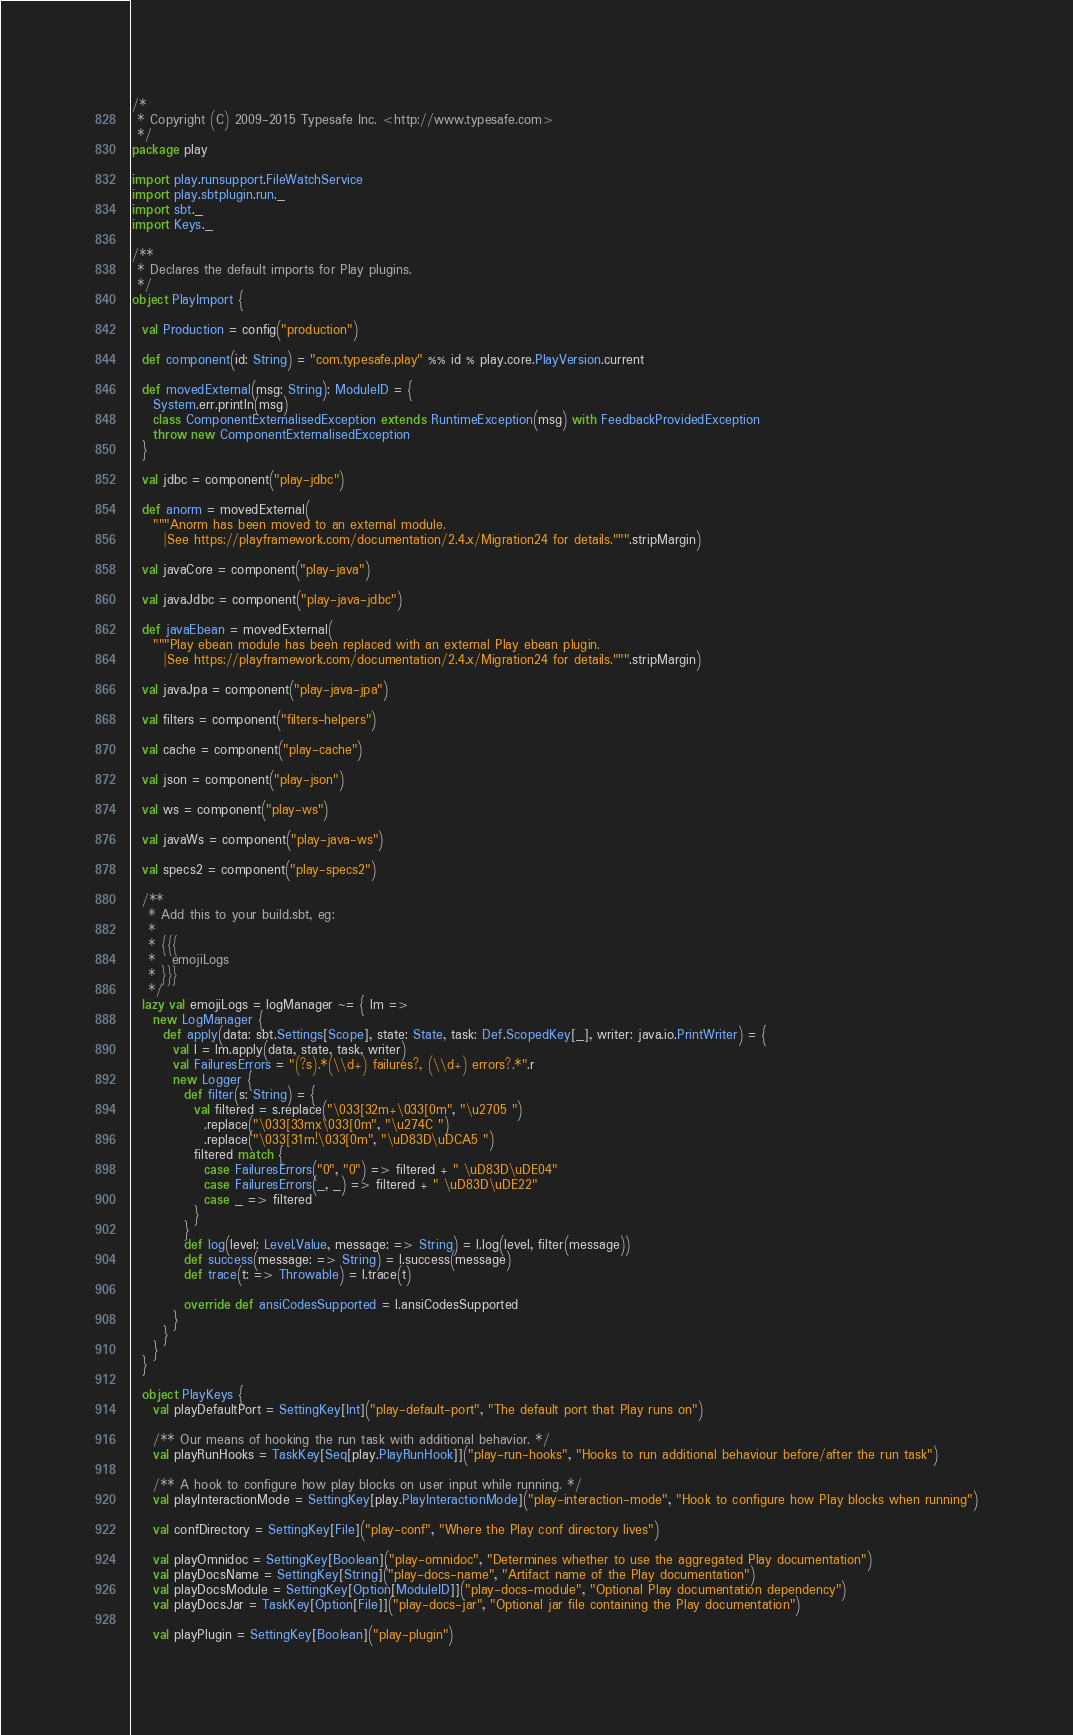<code> <loc_0><loc_0><loc_500><loc_500><_Scala_>/*
 * Copyright (C) 2009-2015 Typesafe Inc. <http://www.typesafe.com>
 */
package play

import play.runsupport.FileWatchService
import play.sbtplugin.run._
import sbt._
import Keys._

/**
 * Declares the default imports for Play plugins.
 */
object PlayImport {

  val Production = config("production")

  def component(id: String) = "com.typesafe.play" %% id % play.core.PlayVersion.current

  def movedExternal(msg: String): ModuleID = {
    System.err.println(msg)
    class ComponentExternalisedException extends RuntimeException(msg) with FeedbackProvidedException
    throw new ComponentExternalisedException
  }

  val jdbc = component("play-jdbc")

  def anorm = movedExternal(
    """Anorm has been moved to an external module.
      |See https://playframework.com/documentation/2.4.x/Migration24 for details.""".stripMargin)

  val javaCore = component("play-java")

  val javaJdbc = component("play-java-jdbc")

  def javaEbean = movedExternal(
    """Play ebean module has been replaced with an external Play ebean plugin.
      |See https://playframework.com/documentation/2.4.x/Migration24 for details.""".stripMargin)

  val javaJpa = component("play-java-jpa")

  val filters = component("filters-helpers")

  val cache = component("play-cache")

  val json = component("play-json")

  val ws = component("play-ws")

  val javaWs = component("play-java-ws")

  val specs2 = component("play-specs2")

  /**
   * Add this to your build.sbt, eg:
   *
   * {{{
   *   emojiLogs
   * }}}
   */
  lazy val emojiLogs = logManager ~= { lm =>
    new LogManager {
      def apply(data: sbt.Settings[Scope], state: State, task: Def.ScopedKey[_], writer: java.io.PrintWriter) = {
        val l = lm.apply(data, state, task, writer)
        val FailuresErrors = "(?s).*(\\d+) failures?, (\\d+) errors?.*".r
        new Logger {
          def filter(s: String) = {
            val filtered = s.replace("\033[32m+\033[0m", "\u2705 ")
              .replace("\033[33mx\033[0m", "\u274C ")
              .replace("\033[31m!\033[0m", "\uD83D\uDCA5 ")
            filtered match {
              case FailuresErrors("0", "0") => filtered + " \uD83D\uDE04"
              case FailuresErrors(_, _) => filtered + " \uD83D\uDE22"
              case _ => filtered
            }
          }
          def log(level: Level.Value, message: => String) = l.log(level, filter(message))
          def success(message: => String) = l.success(message)
          def trace(t: => Throwable) = l.trace(t)

          override def ansiCodesSupported = l.ansiCodesSupported
        }
      }
    }
  }

  object PlayKeys {
    val playDefaultPort = SettingKey[Int]("play-default-port", "The default port that Play runs on")

    /** Our means of hooking the run task with additional behavior. */
    val playRunHooks = TaskKey[Seq[play.PlayRunHook]]("play-run-hooks", "Hooks to run additional behaviour before/after the run task")

    /** A hook to configure how play blocks on user input while running. */
    val playInteractionMode = SettingKey[play.PlayInteractionMode]("play-interaction-mode", "Hook to configure how Play blocks when running")

    val confDirectory = SettingKey[File]("play-conf", "Where the Play conf directory lives")

    val playOmnidoc = SettingKey[Boolean]("play-omnidoc", "Determines whether to use the aggregated Play documentation")
    val playDocsName = SettingKey[String]("play-docs-name", "Artifact name of the Play documentation")
    val playDocsModule = SettingKey[Option[ModuleID]]("play-docs-module", "Optional Play documentation dependency")
    val playDocsJar = TaskKey[Option[File]]("play-docs-jar", "Optional jar file containing the Play documentation")

    val playPlugin = SettingKey[Boolean]("play-plugin")
</code> 